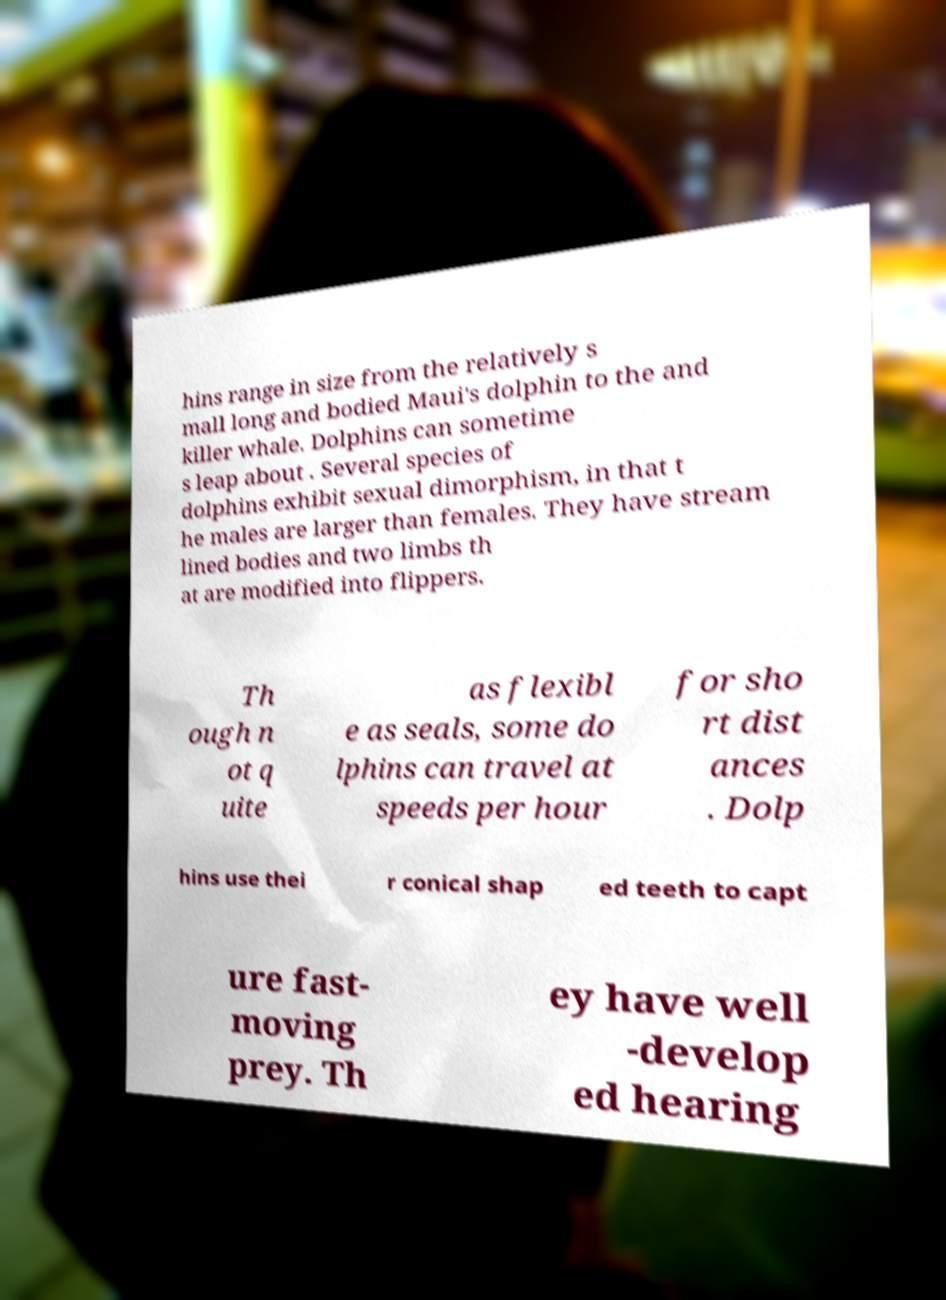What messages or text are displayed in this image? I need them in a readable, typed format. hins range in size from the relatively s mall long and bodied Maui's dolphin to the and killer whale. Dolphins can sometime s leap about . Several species of dolphins exhibit sexual dimorphism, in that t he males are larger than females. They have stream lined bodies and two limbs th at are modified into flippers. Th ough n ot q uite as flexibl e as seals, some do lphins can travel at speeds per hour for sho rt dist ances . Dolp hins use thei r conical shap ed teeth to capt ure fast- moving prey. Th ey have well -develop ed hearing 